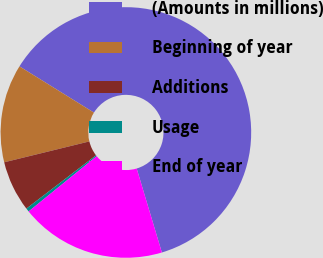Convert chart. <chart><loc_0><loc_0><loc_500><loc_500><pie_chart><fcel>(Amounts in millions)<fcel>Beginning of year<fcel>Additions<fcel>Usage<fcel>End of year<nl><fcel>61.52%<fcel>12.67%<fcel>6.57%<fcel>0.46%<fcel>18.78%<nl></chart> 